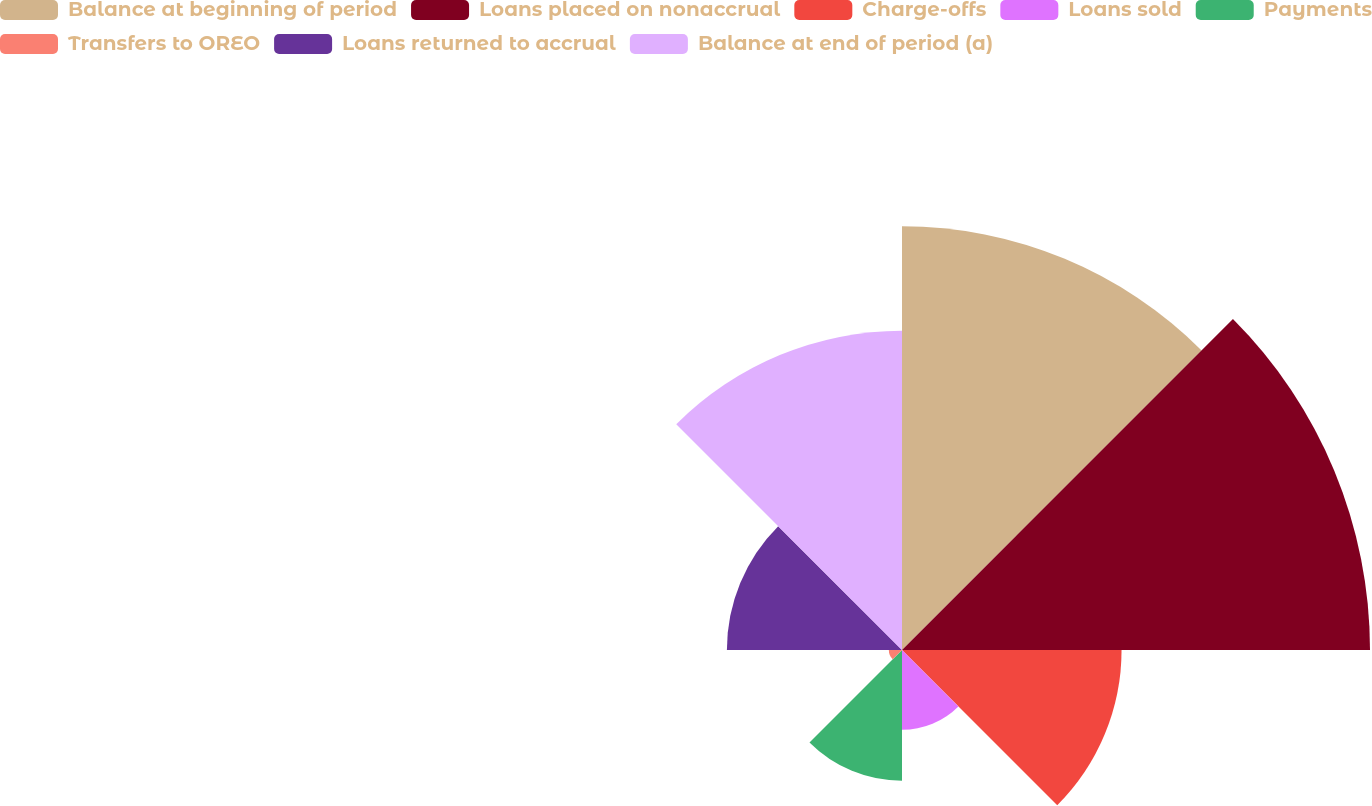<chart> <loc_0><loc_0><loc_500><loc_500><pie_chart><fcel>Balance at beginning of period<fcel>Loans placed on nonaccrual<fcel>Charge-offs<fcel>Loans sold<fcel>Payments<fcel>Transfers to OREO<fcel>Loans returned to accrual<fcel>Balance at end of period (a)<nl><fcel>23.16%<fcel>25.58%<fcel>12.0%<fcel>4.36%<fcel>7.15%<fcel>0.72%<fcel>9.57%<fcel>17.45%<nl></chart> 